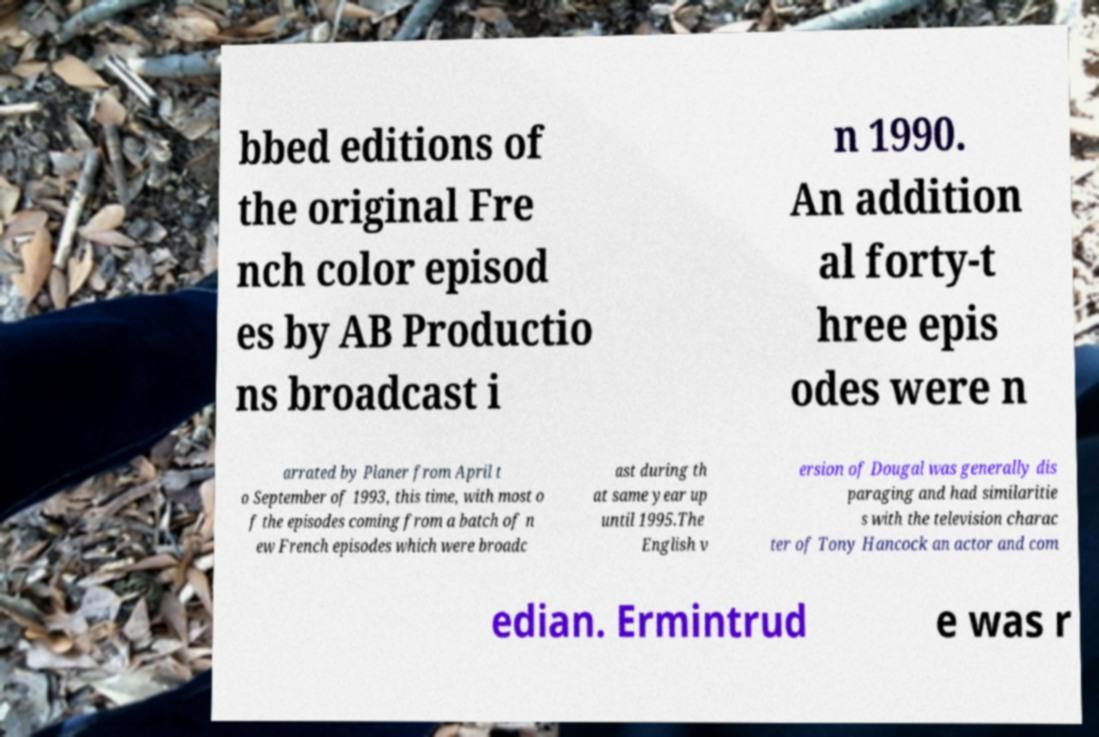Can you read and provide the text displayed in the image?This photo seems to have some interesting text. Can you extract and type it out for me? bbed editions of the original Fre nch color episod es by AB Productio ns broadcast i n 1990. An addition al forty-t hree epis odes were n arrated by Planer from April t o September of 1993, this time, with most o f the episodes coming from a batch of n ew French episodes which were broadc ast during th at same year up until 1995.The English v ersion of Dougal was generally dis paraging and had similaritie s with the television charac ter of Tony Hancock an actor and com edian. Ermintrud e was r 